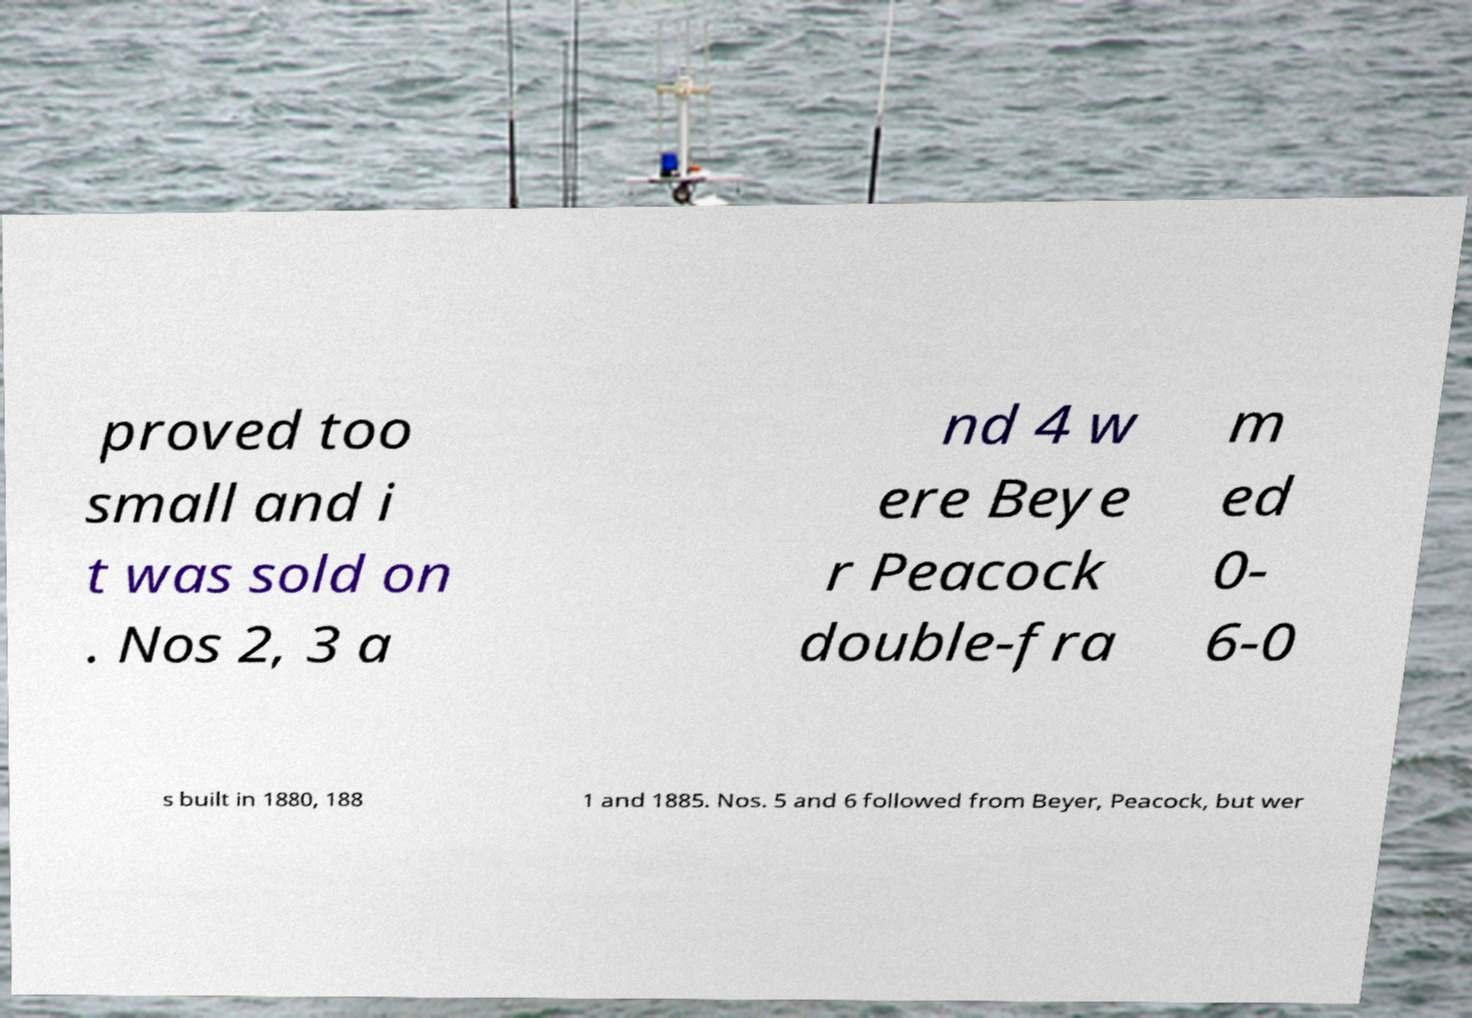Can you accurately transcribe the text from the provided image for me? proved too small and i t was sold on . Nos 2, 3 a nd 4 w ere Beye r Peacock double-fra m ed 0- 6-0 s built in 1880, 188 1 and 1885. Nos. 5 and 6 followed from Beyer, Peacock, but wer 